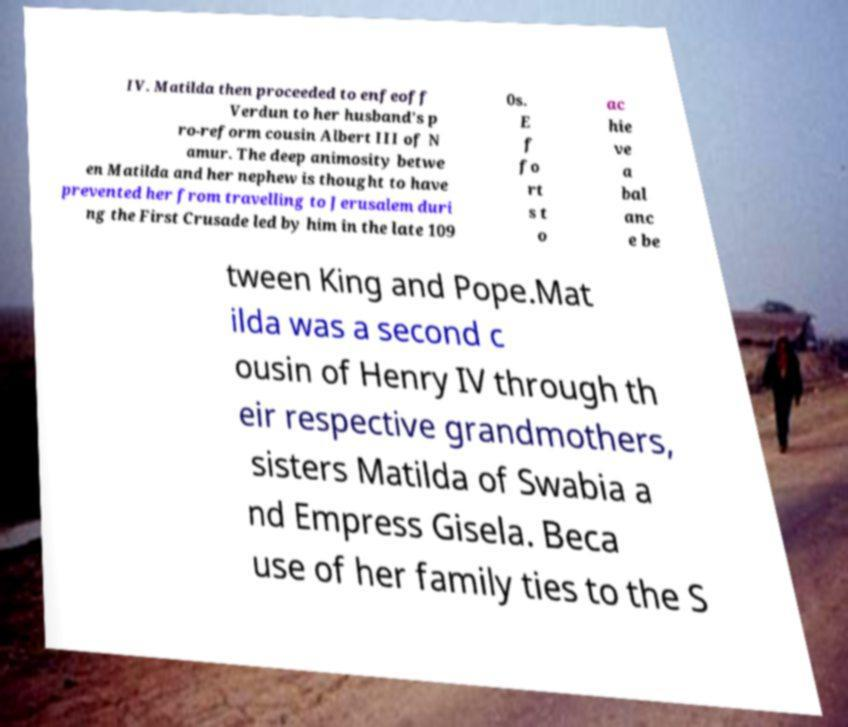Please identify and transcribe the text found in this image. IV. Matilda then proceeded to enfeoff Verdun to her husband's p ro-reform cousin Albert III of N amur. The deep animosity betwe en Matilda and her nephew is thought to have prevented her from travelling to Jerusalem duri ng the First Crusade led by him in the late 109 0s. E f fo rt s t o ac hie ve a bal anc e be tween King and Pope.Mat ilda was a second c ousin of Henry IV through th eir respective grandmothers, sisters Matilda of Swabia a nd Empress Gisela. Beca use of her family ties to the S 